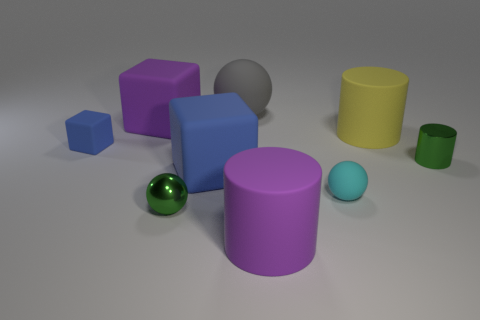Add 1 large matte blocks. How many objects exist? 10 Subtract all blocks. How many objects are left? 6 Subtract 0 yellow blocks. How many objects are left? 9 Subtract all big matte cylinders. Subtract all cylinders. How many objects are left? 4 Add 4 small metal things. How many small metal things are left? 6 Add 7 gray objects. How many gray objects exist? 8 